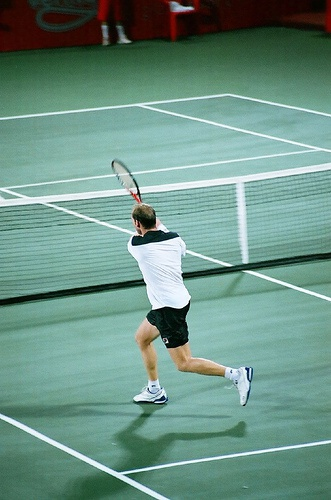Describe the objects in this image and their specific colors. I can see people in black, white, darkgray, and teal tones, people in black, maroon, gray, and darkgray tones, and tennis racket in black, darkgray, lightgray, and lightblue tones in this image. 